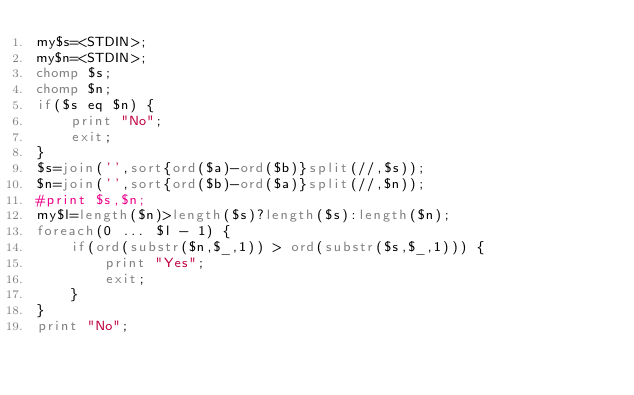Convert code to text. <code><loc_0><loc_0><loc_500><loc_500><_Perl_>my$s=<STDIN>;
my$n=<STDIN>;
chomp $s;
chomp $n;
if($s eq $n) {
    print "No";
    exit;
}
$s=join('',sort{ord($a)-ord($b)}split(//,$s));
$n=join('',sort{ord($b)-ord($a)}split(//,$n));
#print $s,$n;
my$l=length($n)>length($s)?length($s):length($n);
foreach(0 ... $l - 1) {
    if(ord(substr($n,$_,1)) > ord(substr($s,$_,1))) {
        print "Yes";
        exit;
    }
}
print "No";</code> 